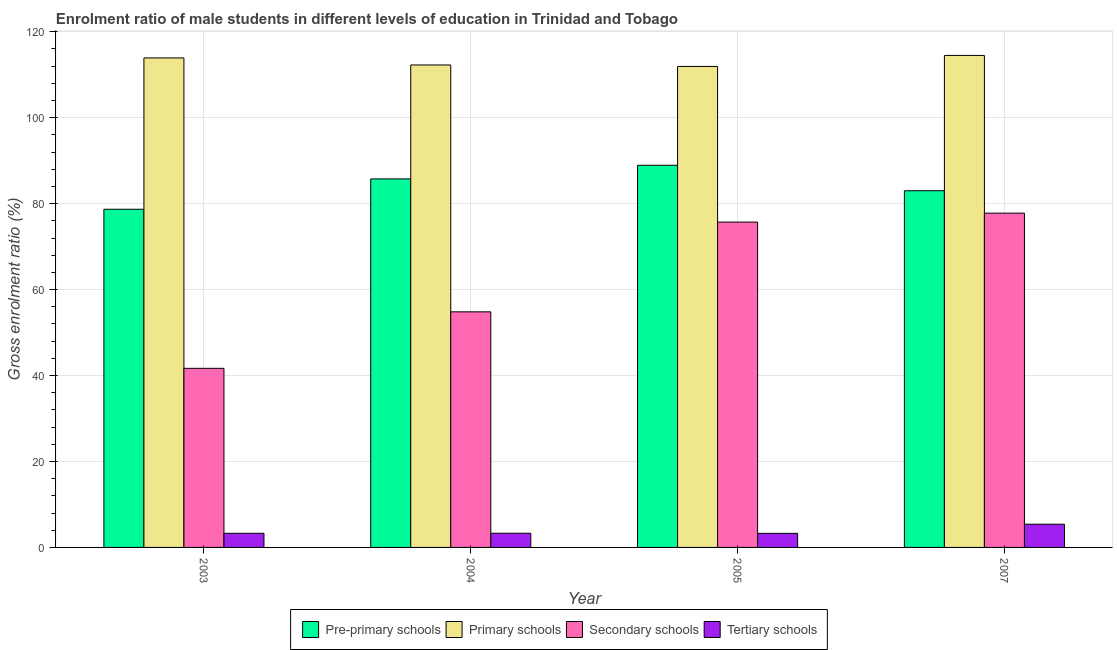How many different coloured bars are there?
Keep it short and to the point. 4. How many groups of bars are there?
Make the answer very short. 4. How many bars are there on the 1st tick from the right?
Give a very brief answer. 4. What is the label of the 1st group of bars from the left?
Offer a very short reply. 2003. In how many cases, is the number of bars for a given year not equal to the number of legend labels?
Provide a short and direct response. 0. What is the gross enrolment ratio(female) in tertiary schools in 2005?
Your answer should be compact. 3.27. Across all years, what is the maximum gross enrolment ratio(female) in tertiary schools?
Your answer should be compact. 5.4. Across all years, what is the minimum gross enrolment ratio(female) in secondary schools?
Provide a succinct answer. 41.67. In which year was the gross enrolment ratio(female) in tertiary schools minimum?
Your answer should be compact. 2005. What is the total gross enrolment ratio(female) in primary schools in the graph?
Keep it short and to the point. 452.57. What is the difference between the gross enrolment ratio(female) in secondary schools in 2004 and that in 2007?
Your response must be concise. -22.96. What is the difference between the gross enrolment ratio(female) in secondary schools in 2007 and the gross enrolment ratio(female) in primary schools in 2003?
Offer a terse response. 36.11. What is the average gross enrolment ratio(female) in pre-primary schools per year?
Make the answer very short. 84.09. What is the ratio of the gross enrolment ratio(female) in primary schools in 2003 to that in 2005?
Give a very brief answer. 1.02. Is the gross enrolment ratio(female) in pre-primary schools in 2004 less than that in 2005?
Give a very brief answer. Yes. Is the difference between the gross enrolment ratio(female) in primary schools in 2003 and 2004 greater than the difference between the gross enrolment ratio(female) in pre-primary schools in 2003 and 2004?
Make the answer very short. No. What is the difference between the highest and the second highest gross enrolment ratio(female) in secondary schools?
Offer a very short reply. 2.08. What is the difference between the highest and the lowest gross enrolment ratio(female) in tertiary schools?
Offer a very short reply. 2.13. In how many years, is the gross enrolment ratio(female) in tertiary schools greater than the average gross enrolment ratio(female) in tertiary schools taken over all years?
Ensure brevity in your answer.  1. Is it the case that in every year, the sum of the gross enrolment ratio(female) in primary schools and gross enrolment ratio(female) in pre-primary schools is greater than the sum of gross enrolment ratio(female) in secondary schools and gross enrolment ratio(female) in tertiary schools?
Offer a very short reply. No. What does the 4th bar from the left in 2004 represents?
Your answer should be compact. Tertiary schools. What does the 4th bar from the right in 2003 represents?
Your answer should be very brief. Pre-primary schools. How many years are there in the graph?
Provide a short and direct response. 4. Are the values on the major ticks of Y-axis written in scientific E-notation?
Give a very brief answer. No. Does the graph contain any zero values?
Offer a very short reply. No. Does the graph contain grids?
Offer a terse response. Yes. Where does the legend appear in the graph?
Offer a very short reply. Bottom center. How many legend labels are there?
Your answer should be very brief. 4. How are the legend labels stacked?
Provide a succinct answer. Horizontal. What is the title of the graph?
Offer a terse response. Enrolment ratio of male students in different levels of education in Trinidad and Tobago. What is the label or title of the X-axis?
Your answer should be compact. Year. What is the Gross enrolment ratio (%) in Pre-primary schools in 2003?
Ensure brevity in your answer.  78.69. What is the Gross enrolment ratio (%) in Primary schools in 2003?
Offer a terse response. 113.9. What is the Gross enrolment ratio (%) of Secondary schools in 2003?
Make the answer very short. 41.67. What is the Gross enrolment ratio (%) of Tertiary schools in 2003?
Offer a terse response. 3.28. What is the Gross enrolment ratio (%) in Pre-primary schools in 2004?
Offer a terse response. 85.75. What is the Gross enrolment ratio (%) in Primary schools in 2004?
Provide a short and direct response. 112.26. What is the Gross enrolment ratio (%) in Secondary schools in 2004?
Provide a short and direct response. 54.82. What is the Gross enrolment ratio (%) in Tertiary schools in 2004?
Offer a terse response. 3.3. What is the Gross enrolment ratio (%) of Pre-primary schools in 2005?
Make the answer very short. 88.92. What is the Gross enrolment ratio (%) of Primary schools in 2005?
Your answer should be compact. 111.92. What is the Gross enrolment ratio (%) in Secondary schools in 2005?
Give a very brief answer. 75.7. What is the Gross enrolment ratio (%) of Tertiary schools in 2005?
Your response must be concise. 3.27. What is the Gross enrolment ratio (%) in Pre-primary schools in 2007?
Ensure brevity in your answer.  83. What is the Gross enrolment ratio (%) of Primary schools in 2007?
Keep it short and to the point. 114.48. What is the Gross enrolment ratio (%) of Secondary schools in 2007?
Make the answer very short. 77.78. What is the Gross enrolment ratio (%) in Tertiary schools in 2007?
Keep it short and to the point. 5.4. Across all years, what is the maximum Gross enrolment ratio (%) in Pre-primary schools?
Your response must be concise. 88.92. Across all years, what is the maximum Gross enrolment ratio (%) of Primary schools?
Provide a succinct answer. 114.48. Across all years, what is the maximum Gross enrolment ratio (%) in Secondary schools?
Ensure brevity in your answer.  77.78. Across all years, what is the maximum Gross enrolment ratio (%) of Tertiary schools?
Ensure brevity in your answer.  5.4. Across all years, what is the minimum Gross enrolment ratio (%) in Pre-primary schools?
Ensure brevity in your answer.  78.69. Across all years, what is the minimum Gross enrolment ratio (%) of Primary schools?
Provide a short and direct response. 111.92. Across all years, what is the minimum Gross enrolment ratio (%) in Secondary schools?
Keep it short and to the point. 41.67. Across all years, what is the minimum Gross enrolment ratio (%) of Tertiary schools?
Ensure brevity in your answer.  3.27. What is the total Gross enrolment ratio (%) of Pre-primary schools in the graph?
Provide a succinct answer. 336.37. What is the total Gross enrolment ratio (%) of Primary schools in the graph?
Your answer should be very brief. 452.57. What is the total Gross enrolment ratio (%) in Secondary schools in the graph?
Your answer should be compact. 249.98. What is the total Gross enrolment ratio (%) of Tertiary schools in the graph?
Your response must be concise. 15.26. What is the difference between the Gross enrolment ratio (%) of Pre-primary schools in 2003 and that in 2004?
Offer a terse response. -7.07. What is the difference between the Gross enrolment ratio (%) of Primary schools in 2003 and that in 2004?
Offer a terse response. 1.64. What is the difference between the Gross enrolment ratio (%) in Secondary schools in 2003 and that in 2004?
Your response must be concise. -13.15. What is the difference between the Gross enrolment ratio (%) of Tertiary schools in 2003 and that in 2004?
Provide a short and direct response. -0.02. What is the difference between the Gross enrolment ratio (%) of Pre-primary schools in 2003 and that in 2005?
Your response must be concise. -10.24. What is the difference between the Gross enrolment ratio (%) of Primary schools in 2003 and that in 2005?
Offer a very short reply. 1.98. What is the difference between the Gross enrolment ratio (%) of Secondary schools in 2003 and that in 2005?
Keep it short and to the point. -34.03. What is the difference between the Gross enrolment ratio (%) in Tertiary schools in 2003 and that in 2005?
Keep it short and to the point. 0.01. What is the difference between the Gross enrolment ratio (%) of Pre-primary schools in 2003 and that in 2007?
Ensure brevity in your answer.  -4.31. What is the difference between the Gross enrolment ratio (%) in Primary schools in 2003 and that in 2007?
Offer a very short reply. -0.58. What is the difference between the Gross enrolment ratio (%) of Secondary schools in 2003 and that in 2007?
Keep it short and to the point. -36.11. What is the difference between the Gross enrolment ratio (%) of Tertiary schools in 2003 and that in 2007?
Offer a very short reply. -2.12. What is the difference between the Gross enrolment ratio (%) of Pre-primary schools in 2004 and that in 2005?
Provide a short and direct response. -3.17. What is the difference between the Gross enrolment ratio (%) of Primary schools in 2004 and that in 2005?
Your answer should be compact. 0.34. What is the difference between the Gross enrolment ratio (%) in Secondary schools in 2004 and that in 2005?
Keep it short and to the point. -20.88. What is the difference between the Gross enrolment ratio (%) in Tertiary schools in 2004 and that in 2005?
Provide a succinct answer. 0.03. What is the difference between the Gross enrolment ratio (%) of Pre-primary schools in 2004 and that in 2007?
Offer a very short reply. 2.76. What is the difference between the Gross enrolment ratio (%) in Primary schools in 2004 and that in 2007?
Your answer should be very brief. -2.22. What is the difference between the Gross enrolment ratio (%) in Secondary schools in 2004 and that in 2007?
Offer a very short reply. -22.96. What is the difference between the Gross enrolment ratio (%) in Tertiary schools in 2004 and that in 2007?
Give a very brief answer. -2.1. What is the difference between the Gross enrolment ratio (%) in Pre-primary schools in 2005 and that in 2007?
Provide a short and direct response. 5.93. What is the difference between the Gross enrolment ratio (%) in Primary schools in 2005 and that in 2007?
Your answer should be compact. -2.56. What is the difference between the Gross enrolment ratio (%) in Secondary schools in 2005 and that in 2007?
Your answer should be compact. -2.08. What is the difference between the Gross enrolment ratio (%) in Tertiary schools in 2005 and that in 2007?
Your answer should be compact. -2.13. What is the difference between the Gross enrolment ratio (%) of Pre-primary schools in 2003 and the Gross enrolment ratio (%) of Primary schools in 2004?
Offer a very short reply. -33.57. What is the difference between the Gross enrolment ratio (%) in Pre-primary schools in 2003 and the Gross enrolment ratio (%) in Secondary schools in 2004?
Keep it short and to the point. 23.87. What is the difference between the Gross enrolment ratio (%) in Pre-primary schools in 2003 and the Gross enrolment ratio (%) in Tertiary schools in 2004?
Keep it short and to the point. 75.39. What is the difference between the Gross enrolment ratio (%) in Primary schools in 2003 and the Gross enrolment ratio (%) in Secondary schools in 2004?
Your answer should be compact. 59.08. What is the difference between the Gross enrolment ratio (%) of Primary schools in 2003 and the Gross enrolment ratio (%) of Tertiary schools in 2004?
Provide a short and direct response. 110.6. What is the difference between the Gross enrolment ratio (%) in Secondary schools in 2003 and the Gross enrolment ratio (%) in Tertiary schools in 2004?
Your response must be concise. 38.37. What is the difference between the Gross enrolment ratio (%) of Pre-primary schools in 2003 and the Gross enrolment ratio (%) of Primary schools in 2005?
Ensure brevity in your answer.  -33.23. What is the difference between the Gross enrolment ratio (%) of Pre-primary schools in 2003 and the Gross enrolment ratio (%) of Secondary schools in 2005?
Make the answer very short. 2.99. What is the difference between the Gross enrolment ratio (%) in Pre-primary schools in 2003 and the Gross enrolment ratio (%) in Tertiary schools in 2005?
Make the answer very short. 75.42. What is the difference between the Gross enrolment ratio (%) of Primary schools in 2003 and the Gross enrolment ratio (%) of Secondary schools in 2005?
Offer a terse response. 38.2. What is the difference between the Gross enrolment ratio (%) in Primary schools in 2003 and the Gross enrolment ratio (%) in Tertiary schools in 2005?
Your response must be concise. 110.63. What is the difference between the Gross enrolment ratio (%) in Secondary schools in 2003 and the Gross enrolment ratio (%) in Tertiary schools in 2005?
Offer a very short reply. 38.4. What is the difference between the Gross enrolment ratio (%) of Pre-primary schools in 2003 and the Gross enrolment ratio (%) of Primary schools in 2007?
Make the answer very short. -35.8. What is the difference between the Gross enrolment ratio (%) in Pre-primary schools in 2003 and the Gross enrolment ratio (%) in Secondary schools in 2007?
Give a very brief answer. 0.91. What is the difference between the Gross enrolment ratio (%) in Pre-primary schools in 2003 and the Gross enrolment ratio (%) in Tertiary schools in 2007?
Give a very brief answer. 73.29. What is the difference between the Gross enrolment ratio (%) of Primary schools in 2003 and the Gross enrolment ratio (%) of Secondary schools in 2007?
Ensure brevity in your answer.  36.12. What is the difference between the Gross enrolment ratio (%) of Primary schools in 2003 and the Gross enrolment ratio (%) of Tertiary schools in 2007?
Keep it short and to the point. 108.5. What is the difference between the Gross enrolment ratio (%) in Secondary schools in 2003 and the Gross enrolment ratio (%) in Tertiary schools in 2007?
Ensure brevity in your answer.  36.27. What is the difference between the Gross enrolment ratio (%) of Pre-primary schools in 2004 and the Gross enrolment ratio (%) of Primary schools in 2005?
Your answer should be compact. -26.16. What is the difference between the Gross enrolment ratio (%) of Pre-primary schools in 2004 and the Gross enrolment ratio (%) of Secondary schools in 2005?
Offer a terse response. 10.05. What is the difference between the Gross enrolment ratio (%) of Pre-primary schools in 2004 and the Gross enrolment ratio (%) of Tertiary schools in 2005?
Keep it short and to the point. 82.48. What is the difference between the Gross enrolment ratio (%) of Primary schools in 2004 and the Gross enrolment ratio (%) of Secondary schools in 2005?
Offer a very short reply. 36.56. What is the difference between the Gross enrolment ratio (%) of Primary schools in 2004 and the Gross enrolment ratio (%) of Tertiary schools in 2005?
Provide a succinct answer. 108.99. What is the difference between the Gross enrolment ratio (%) of Secondary schools in 2004 and the Gross enrolment ratio (%) of Tertiary schools in 2005?
Ensure brevity in your answer.  51.55. What is the difference between the Gross enrolment ratio (%) of Pre-primary schools in 2004 and the Gross enrolment ratio (%) of Primary schools in 2007?
Your answer should be very brief. -28.73. What is the difference between the Gross enrolment ratio (%) in Pre-primary schools in 2004 and the Gross enrolment ratio (%) in Secondary schools in 2007?
Make the answer very short. 7.97. What is the difference between the Gross enrolment ratio (%) of Pre-primary schools in 2004 and the Gross enrolment ratio (%) of Tertiary schools in 2007?
Provide a succinct answer. 80.35. What is the difference between the Gross enrolment ratio (%) in Primary schools in 2004 and the Gross enrolment ratio (%) in Secondary schools in 2007?
Your answer should be compact. 34.48. What is the difference between the Gross enrolment ratio (%) of Primary schools in 2004 and the Gross enrolment ratio (%) of Tertiary schools in 2007?
Offer a terse response. 106.86. What is the difference between the Gross enrolment ratio (%) of Secondary schools in 2004 and the Gross enrolment ratio (%) of Tertiary schools in 2007?
Provide a succinct answer. 49.42. What is the difference between the Gross enrolment ratio (%) in Pre-primary schools in 2005 and the Gross enrolment ratio (%) in Primary schools in 2007?
Your response must be concise. -25.56. What is the difference between the Gross enrolment ratio (%) in Pre-primary schools in 2005 and the Gross enrolment ratio (%) in Secondary schools in 2007?
Give a very brief answer. 11.14. What is the difference between the Gross enrolment ratio (%) of Pre-primary schools in 2005 and the Gross enrolment ratio (%) of Tertiary schools in 2007?
Provide a short and direct response. 83.52. What is the difference between the Gross enrolment ratio (%) of Primary schools in 2005 and the Gross enrolment ratio (%) of Secondary schools in 2007?
Your answer should be compact. 34.14. What is the difference between the Gross enrolment ratio (%) of Primary schools in 2005 and the Gross enrolment ratio (%) of Tertiary schools in 2007?
Keep it short and to the point. 106.52. What is the difference between the Gross enrolment ratio (%) in Secondary schools in 2005 and the Gross enrolment ratio (%) in Tertiary schools in 2007?
Your answer should be compact. 70.3. What is the average Gross enrolment ratio (%) in Pre-primary schools per year?
Provide a short and direct response. 84.09. What is the average Gross enrolment ratio (%) of Primary schools per year?
Your answer should be compact. 113.14. What is the average Gross enrolment ratio (%) in Secondary schools per year?
Ensure brevity in your answer.  62.49. What is the average Gross enrolment ratio (%) of Tertiary schools per year?
Offer a very short reply. 3.81. In the year 2003, what is the difference between the Gross enrolment ratio (%) in Pre-primary schools and Gross enrolment ratio (%) in Primary schools?
Provide a succinct answer. -35.21. In the year 2003, what is the difference between the Gross enrolment ratio (%) in Pre-primary schools and Gross enrolment ratio (%) in Secondary schools?
Ensure brevity in your answer.  37.02. In the year 2003, what is the difference between the Gross enrolment ratio (%) in Pre-primary schools and Gross enrolment ratio (%) in Tertiary schools?
Your answer should be very brief. 75.4. In the year 2003, what is the difference between the Gross enrolment ratio (%) of Primary schools and Gross enrolment ratio (%) of Secondary schools?
Your answer should be very brief. 72.23. In the year 2003, what is the difference between the Gross enrolment ratio (%) of Primary schools and Gross enrolment ratio (%) of Tertiary schools?
Provide a succinct answer. 110.62. In the year 2003, what is the difference between the Gross enrolment ratio (%) of Secondary schools and Gross enrolment ratio (%) of Tertiary schools?
Your answer should be compact. 38.39. In the year 2004, what is the difference between the Gross enrolment ratio (%) in Pre-primary schools and Gross enrolment ratio (%) in Primary schools?
Ensure brevity in your answer.  -26.51. In the year 2004, what is the difference between the Gross enrolment ratio (%) in Pre-primary schools and Gross enrolment ratio (%) in Secondary schools?
Provide a short and direct response. 30.93. In the year 2004, what is the difference between the Gross enrolment ratio (%) of Pre-primary schools and Gross enrolment ratio (%) of Tertiary schools?
Provide a succinct answer. 82.45. In the year 2004, what is the difference between the Gross enrolment ratio (%) in Primary schools and Gross enrolment ratio (%) in Secondary schools?
Offer a terse response. 57.44. In the year 2004, what is the difference between the Gross enrolment ratio (%) in Primary schools and Gross enrolment ratio (%) in Tertiary schools?
Your answer should be compact. 108.96. In the year 2004, what is the difference between the Gross enrolment ratio (%) of Secondary schools and Gross enrolment ratio (%) of Tertiary schools?
Give a very brief answer. 51.52. In the year 2005, what is the difference between the Gross enrolment ratio (%) in Pre-primary schools and Gross enrolment ratio (%) in Primary schools?
Provide a succinct answer. -22.99. In the year 2005, what is the difference between the Gross enrolment ratio (%) in Pre-primary schools and Gross enrolment ratio (%) in Secondary schools?
Provide a short and direct response. 13.22. In the year 2005, what is the difference between the Gross enrolment ratio (%) of Pre-primary schools and Gross enrolment ratio (%) of Tertiary schools?
Provide a short and direct response. 85.65. In the year 2005, what is the difference between the Gross enrolment ratio (%) in Primary schools and Gross enrolment ratio (%) in Secondary schools?
Keep it short and to the point. 36.22. In the year 2005, what is the difference between the Gross enrolment ratio (%) in Primary schools and Gross enrolment ratio (%) in Tertiary schools?
Keep it short and to the point. 108.65. In the year 2005, what is the difference between the Gross enrolment ratio (%) in Secondary schools and Gross enrolment ratio (%) in Tertiary schools?
Make the answer very short. 72.43. In the year 2007, what is the difference between the Gross enrolment ratio (%) of Pre-primary schools and Gross enrolment ratio (%) of Primary schools?
Your response must be concise. -31.49. In the year 2007, what is the difference between the Gross enrolment ratio (%) of Pre-primary schools and Gross enrolment ratio (%) of Secondary schools?
Your answer should be very brief. 5.21. In the year 2007, what is the difference between the Gross enrolment ratio (%) in Pre-primary schools and Gross enrolment ratio (%) in Tertiary schools?
Your answer should be compact. 77.6. In the year 2007, what is the difference between the Gross enrolment ratio (%) in Primary schools and Gross enrolment ratio (%) in Secondary schools?
Ensure brevity in your answer.  36.7. In the year 2007, what is the difference between the Gross enrolment ratio (%) in Primary schools and Gross enrolment ratio (%) in Tertiary schools?
Keep it short and to the point. 109.08. In the year 2007, what is the difference between the Gross enrolment ratio (%) in Secondary schools and Gross enrolment ratio (%) in Tertiary schools?
Your response must be concise. 72.38. What is the ratio of the Gross enrolment ratio (%) in Pre-primary schools in 2003 to that in 2004?
Provide a short and direct response. 0.92. What is the ratio of the Gross enrolment ratio (%) of Primary schools in 2003 to that in 2004?
Your answer should be compact. 1.01. What is the ratio of the Gross enrolment ratio (%) in Secondary schools in 2003 to that in 2004?
Give a very brief answer. 0.76. What is the ratio of the Gross enrolment ratio (%) of Pre-primary schools in 2003 to that in 2005?
Provide a succinct answer. 0.88. What is the ratio of the Gross enrolment ratio (%) of Primary schools in 2003 to that in 2005?
Provide a short and direct response. 1.02. What is the ratio of the Gross enrolment ratio (%) of Secondary schools in 2003 to that in 2005?
Make the answer very short. 0.55. What is the ratio of the Gross enrolment ratio (%) of Pre-primary schools in 2003 to that in 2007?
Give a very brief answer. 0.95. What is the ratio of the Gross enrolment ratio (%) of Secondary schools in 2003 to that in 2007?
Offer a very short reply. 0.54. What is the ratio of the Gross enrolment ratio (%) of Tertiary schools in 2003 to that in 2007?
Your answer should be very brief. 0.61. What is the ratio of the Gross enrolment ratio (%) of Pre-primary schools in 2004 to that in 2005?
Offer a terse response. 0.96. What is the ratio of the Gross enrolment ratio (%) of Primary schools in 2004 to that in 2005?
Your response must be concise. 1. What is the ratio of the Gross enrolment ratio (%) of Secondary schools in 2004 to that in 2005?
Keep it short and to the point. 0.72. What is the ratio of the Gross enrolment ratio (%) in Tertiary schools in 2004 to that in 2005?
Provide a succinct answer. 1.01. What is the ratio of the Gross enrolment ratio (%) in Pre-primary schools in 2004 to that in 2007?
Give a very brief answer. 1.03. What is the ratio of the Gross enrolment ratio (%) in Primary schools in 2004 to that in 2007?
Give a very brief answer. 0.98. What is the ratio of the Gross enrolment ratio (%) in Secondary schools in 2004 to that in 2007?
Make the answer very short. 0.7. What is the ratio of the Gross enrolment ratio (%) of Tertiary schools in 2004 to that in 2007?
Your response must be concise. 0.61. What is the ratio of the Gross enrolment ratio (%) of Pre-primary schools in 2005 to that in 2007?
Provide a succinct answer. 1.07. What is the ratio of the Gross enrolment ratio (%) in Primary schools in 2005 to that in 2007?
Make the answer very short. 0.98. What is the ratio of the Gross enrolment ratio (%) of Secondary schools in 2005 to that in 2007?
Keep it short and to the point. 0.97. What is the ratio of the Gross enrolment ratio (%) in Tertiary schools in 2005 to that in 2007?
Ensure brevity in your answer.  0.61. What is the difference between the highest and the second highest Gross enrolment ratio (%) in Pre-primary schools?
Your answer should be compact. 3.17. What is the difference between the highest and the second highest Gross enrolment ratio (%) of Primary schools?
Make the answer very short. 0.58. What is the difference between the highest and the second highest Gross enrolment ratio (%) in Secondary schools?
Keep it short and to the point. 2.08. What is the difference between the highest and the second highest Gross enrolment ratio (%) in Tertiary schools?
Ensure brevity in your answer.  2.1. What is the difference between the highest and the lowest Gross enrolment ratio (%) of Pre-primary schools?
Your response must be concise. 10.24. What is the difference between the highest and the lowest Gross enrolment ratio (%) in Primary schools?
Offer a very short reply. 2.56. What is the difference between the highest and the lowest Gross enrolment ratio (%) in Secondary schools?
Make the answer very short. 36.11. What is the difference between the highest and the lowest Gross enrolment ratio (%) of Tertiary schools?
Your response must be concise. 2.13. 